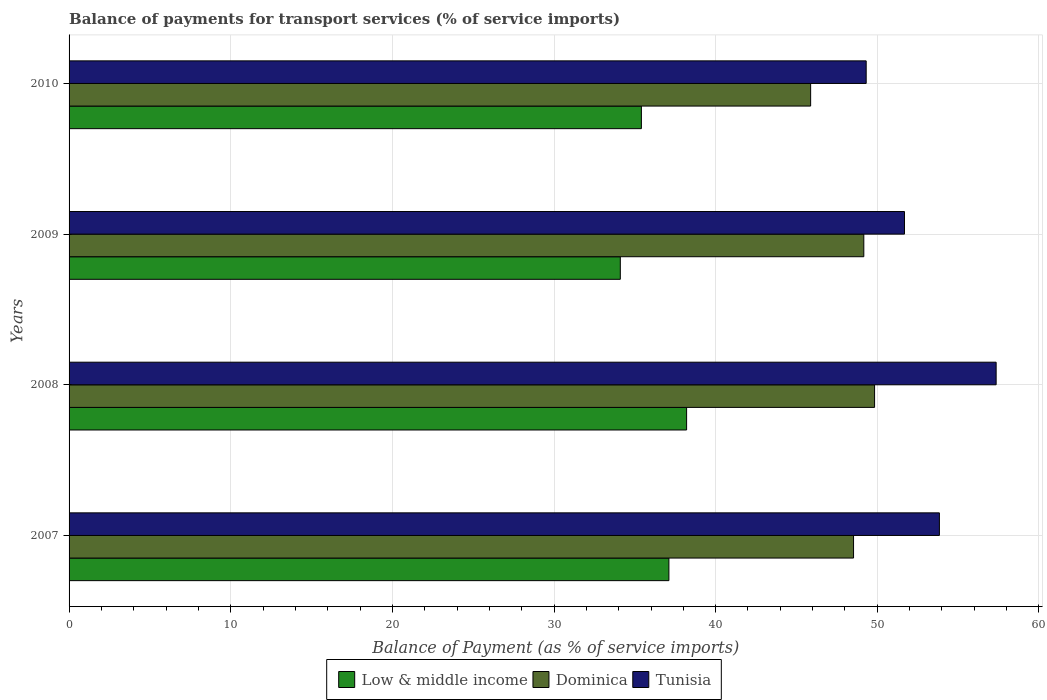How many different coloured bars are there?
Give a very brief answer. 3. How many groups of bars are there?
Provide a short and direct response. 4. Are the number of bars per tick equal to the number of legend labels?
Provide a succinct answer. Yes. How many bars are there on the 3rd tick from the top?
Ensure brevity in your answer.  3. What is the balance of payments for transport services in Low & middle income in 2007?
Provide a short and direct response. 37.11. Across all years, what is the maximum balance of payments for transport services in Tunisia?
Make the answer very short. 57.35. Across all years, what is the minimum balance of payments for transport services in Tunisia?
Your answer should be very brief. 49.31. In which year was the balance of payments for transport services in Low & middle income maximum?
Ensure brevity in your answer.  2008. In which year was the balance of payments for transport services in Low & middle income minimum?
Your response must be concise. 2009. What is the total balance of payments for transport services in Tunisia in the graph?
Your response must be concise. 212.19. What is the difference between the balance of payments for transport services in Low & middle income in 2009 and that in 2010?
Your response must be concise. -1.3. What is the difference between the balance of payments for transport services in Dominica in 2009 and the balance of payments for transport services in Tunisia in 2007?
Give a very brief answer. -4.68. What is the average balance of payments for transport services in Dominica per year?
Give a very brief answer. 48.35. In the year 2007, what is the difference between the balance of payments for transport services in Tunisia and balance of payments for transport services in Low & middle income?
Your answer should be compact. 16.73. What is the ratio of the balance of payments for transport services in Tunisia in 2008 to that in 2009?
Provide a short and direct response. 1.11. Is the balance of payments for transport services in Low & middle income in 2007 less than that in 2008?
Provide a short and direct response. Yes. Is the difference between the balance of payments for transport services in Tunisia in 2007 and 2008 greater than the difference between the balance of payments for transport services in Low & middle income in 2007 and 2008?
Keep it short and to the point. No. What is the difference between the highest and the second highest balance of payments for transport services in Tunisia?
Your answer should be compact. 3.51. What is the difference between the highest and the lowest balance of payments for transport services in Tunisia?
Ensure brevity in your answer.  8.04. In how many years, is the balance of payments for transport services in Tunisia greater than the average balance of payments for transport services in Tunisia taken over all years?
Your response must be concise. 2. Is it the case that in every year, the sum of the balance of payments for transport services in Dominica and balance of payments for transport services in Tunisia is greater than the balance of payments for transport services in Low & middle income?
Make the answer very short. Yes. How many years are there in the graph?
Your response must be concise. 4. What is the difference between two consecutive major ticks on the X-axis?
Your response must be concise. 10. Does the graph contain any zero values?
Provide a short and direct response. No. Does the graph contain grids?
Your answer should be compact. Yes. Where does the legend appear in the graph?
Offer a very short reply. Bottom center. What is the title of the graph?
Ensure brevity in your answer.  Balance of payments for transport services (% of service imports). Does "Macao" appear as one of the legend labels in the graph?
Your response must be concise. No. What is the label or title of the X-axis?
Give a very brief answer. Balance of Payment (as % of service imports). What is the Balance of Payment (as % of service imports) of Low & middle income in 2007?
Provide a short and direct response. 37.11. What is the Balance of Payment (as % of service imports) in Dominica in 2007?
Your answer should be very brief. 48.53. What is the Balance of Payment (as % of service imports) in Tunisia in 2007?
Make the answer very short. 53.84. What is the Balance of Payment (as % of service imports) of Low & middle income in 2008?
Offer a terse response. 38.2. What is the Balance of Payment (as % of service imports) in Dominica in 2008?
Give a very brief answer. 49.83. What is the Balance of Payment (as % of service imports) of Tunisia in 2008?
Give a very brief answer. 57.35. What is the Balance of Payment (as % of service imports) in Low & middle income in 2009?
Your response must be concise. 34.1. What is the Balance of Payment (as % of service imports) of Dominica in 2009?
Offer a terse response. 49.17. What is the Balance of Payment (as % of service imports) of Tunisia in 2009?
Make the answer very short. 51.68. What is the Balance of Payment (as % of service imports) in Low & middle income in 2010?
Offer a terse response. 35.41. What is the Balance of Payment (as % of service imports) of Dominica in 2010?
Offer a terse response. 45.88. What is the Balance of Payment (as % of service imports) in Tunisia in 2010?
Give a very brief answer. 49.31. Across all years, what is the maximum Balance of Payment (as % of service imports) in Low & middle income?
Offer a very short reply. 38.2. Across all years, what is the maximum Balance of Payment (as % of service imports) in Dominica?
Offer a very short reply. 49.83. Across all years, what is the maximum Balance of Payment (as % of service imports) in Tunisia?
Offer a terse response. 57.35. Across all years, what is the minimum Balance of Payment (as % of service imports) in Low & middle income?
Offer a very short reply. 34.1. Across all years, what is the minimum Balance of Payment (as % of service imports) of Dominica?
Your answer should be very brief. 45.88. Across all years, what is the minimum Balance of Payment (as % of service imports) of Tunisia?
Keep it short and to the point. 49.31. What is the total Balance of Payment (as % of service imports) of Low & middle income in the graph?
Give a very brief answer. 144.82. What is the total Balance of Payment (as % of service imports) in Dominica in the graph?
Ensure brevity in your answer.  193.4. What is the total Balance of Payment (as % of service imports) of Tunisia in the graph?
Ensure brevity in your answer.  212.19. What is the difference between the Balance of Payment (as % of service imports) in Low & middle income in 2007 and that in 2008?
Your answer should be very brief. -1.1. What is the difference between the Balance of Payment (as % of service imports) of Dominica in 2007 and that in 2008?
Keep it short and to the point. -1.3. What is the difference between the Balance of Payment (as % of service imports) of Tunisia in 2007 and that in 2008?
Provide a succinct answer. -3.51. What is the difference between the Balance of Payment (as % of service imports) of Low & middle income in 2007 and that in 2009?
Offer a very short reply. 3.01. What is the difference between the Balance of Payment (as % of service imports) in Dominica in 2007 and that in 2009?
Give a very brief answer. -0.63. What is the difference between the Balance of Payment (as % of service imports) in Tunisia in 2007 and that in 2009?
Offer a very short reply. 2.16. What is the difference between the Balance of Payment (as % of service imports) in Low & middle income in 2007 and that in 2010?
Make the answer very short. 1.7. What is the difference between the Balance of Payment (as % of service imports) of Dominica in 2007 and that in 2010?
Provide a short and direct response. 2.65. What is the difference between the Balance of Payment (as % of service imports) in Tunisia in 2007 and that in 2010?
Your answer should be compact. 4.53. What is the difference between the Balance of Payment (as % of service imports) in Low & middle income in 2008 and that in 2009?
Keep it short and to the point. 4.1. What is the difference between the Balance of Payment (as % of service imports) in Dominica in 2008 and that in 2009?
Your response must be concise. 0.67. What is the difference between the Balance of Payment (as % of service imports) in Tunisia in 2008 and that in 2009?
Your answer should be compact. 5.67. What is the difference between the Balance of Payment (as % of service imports) of Low & middle income in 2008 and that in 2010?
Ensure brevity in your answer.  2.8. What is the difference between the Balance of Payment (as % of service imports) of Dominica in 2008 and that in 2010?
Keep it short and to the point. 3.95. What is the difference between the Balance of Payment (as % of service imports) of Tunisia in 2008 and that in 2010?
Keep it short and to the point. 8.04. What is the difference between the Balance of Payment (as % of service imports) of Low & middle income in 2009 and that in 2010?
Keep it short and to the point. -1.3. What is the difference between the Balance of Payment (as % of service imports) in Dominica in 2009 and that in 2010?
Your answer should be compact. 3.29. What is the difference between the Balance of Payment (as % of service imports) in Tunisia in 2009 and that in 2010?
Provide a succinct answer. 2.37. What is the difference between the Balance of Payment (as % of service imports) in Low & middle income in 2007 and the Balance of Payment (as % of service imports) in Dominica in 2008?
Offer a very short reply. -12.72. What is the difference between the Balance of Payment (as % of service imports) of Low & middle income in 2007 and the Balance of Payment (as % of service imports) of Tunisia in 2008?
Make the answer very short. -20.24. What is the difference between the Balance of Payment (as % of service imports) in Dominica in 2007 and the Balance of Payment (as % of service imports) in Tunisia in 2008?
Your response must be concise. -8.82. What is the difference between the Balance of Payment (as % of service imports) in Low & middle income in 2007 and the Balance of Payment (as % of service imports) in Dominica in 2009?
Offer a very short reply. -12.06. What is the difference between the Balance of Payment (as % of service imports) of Low & middle income in 2007 and the Balance of Payment (as % of service imports) of Tunisia in 2009?
Your response must be concise. -14.57. What is the difference between the Balance of Payment (as % of service imports) of Dominica in 2007 and the Balance of Payment (as % of service imports) of Tunisia in 2009?
Your response must be concise. -3.15. What is the difference between the Balance of Payment (as % of service imports) in Low & middle income in 2007 and the Balance of Payment (as % of service imports) in Dominica in 2010?
Make the answer very short. -8.77. What is the difference between the Balance of Payment (as % of service imports) of Low & middle income in 2007 and the Balance of Payment (as % of service imports) of Tunisia in 2010?
Your answer should be compact. -12.2. What is the difference between the Balance of Payment (as % of service imports) in Dominica in 2007 and the Balance of Payment (as % of service imports) in Tunisia in 2010?
Your response must be concise. -0.78. What is the difference between the Balance of Payment (as % of service imports) in Low & middle income in 2008 and the Balance of Payment (as % of service imports) in Dominica in 2009?
Offer a terse response. -10.96. What is the difference between the Balance of Payment (as % of service imports) of Low & middle income in 2008 and the Balance of Payment (as % of service imports) of Tunisia in 2009?
Offer a very short reply. -13.48. What is the difference between the Balance of Payment (as % of service imports) of Dominica in 2008 and the Balance of Payment (as % of service imports) of Tunisia in 2009?
Provide a succinct answer. -1.85. What is the difference between the Balance of Payment (as % of service imports) in Low & middle income in 2008 and the Balance of Payment (as % of service imports) in Dominica in 2010?
Ensure brevity in your answer.  -7.67. What is the difference between the Balance of Payment (as % of service imports) of Low & middle income in 2008 and the Balance of Payment (as % of service imports) of Tunisia in 2010?
Ensure brevity in your answer.  -11.11. What is the difference between the Balance of Payment (as % of service imports) in Dominica in 2008 and the Balance of Payment (as % of service imports) in Tunisia in 2010?
Give a very brief answer. 0.52. What is the difference between the Balance of Payment (as % of service imports) in Low & middle income in 2009 and the Balance of Payment (as % of service imports) in Dominica in 2010?
Provide a short and direct response. -11.78. What is the difference between the Balance of Payment (as % of service imports) of Low & middle income in 2009 and the Balance of Payment (as % of service imports) of Tunisia in 2010?
Your answer should be very brief. -15.21. What is the difference between the Balance of Payment (as % of service imports) of Dominica in 2009 and the Balance of Payment (as % of service imports) of Tunisia in 2010?
Your answer should be compact. -0.15. What is the average Balance of Payment (as % of service imports) in Low & middle income per year?
Keep it short and to the point. 36.2. What is the average Balance of Payment (as % of service imports) in Dominica per year?
Give a very brief answer. 48.35. What is the average Balance of Payment (as % of service imports) of Tunisia per year?
Provide a succinct answer. 53.05. In the year 2007, what is the difference between the Balance of Payment (as % of service imports) in Low & middle income and Balance of Payment (as % of service imports) in Dominica?
Give a very brief answer. -11.42. In the year 2007, what is the difference between the Balance of Payment (as % of service imports) of Low & middle income and Balance of Payment (as % of service imports) of Tunisia?
Provide a short and direct response. -16.73. In the year 2007, what is the difference between the Balance of Payment (as % of service imports) of Dominica and Balance of Payment (as % of service imports) of Tunisia?
Offer a very short reply. -5.31. In the year 2008, what is the difference between the Balance of Payment (as % of service imports) in Low & middle income and Balance of Payment (as % of service imports) in Dominica?
Offer a terse response. -11.63. In the year 2008, what is the difference between the Balance of Payment (as % of service imports) of Low & middle income and Balance of Payment (as % of service imports) of Tunisia?
Provide a short and direct response. -19.15. In the year 2008, what is the difference between the Balance of Payment (as % of service imports) of Dominica and Balance of Payment (as % of service imports) of Tunisia?
Give a very brief answer. -7.52. In the year 2009, what is the difference between the Balance of Payment (as % of service imports) in Low & middle income and Balance of Payment (as % of service imports) in Dominica?
Your answer should be compact. -15.06. In the year 2009, what is the difference between the Balance of Payment (as % of service imports) in Low & middle income and Balance of Payment (as % of service imports) in Tunisia?
Offer a very short reply. -17.58. In the year 2009, what is the difference between the Balance of Payment (as % of service imports) of Dominica and Balance of Payment (as % of service imports) of Tunisia?
Offer a very short reply. -2.52. In the year 2010, what is the difference between the Balance of Payment (as % of service imports) of Low & middle income and Balance of Payment (as % of service imports) of Dominica?
Give a very brief answer. -10.47. In the year 2010, what is the difference between the Balance of Payment (as % of service imports) of Low & middle income and Balance of Payment (as % of service imports) of Tunisia?
Your answer should be very brief. -13.91. In the year 2010, what is the difference between the Balance of Payment (as % of service imports) of Dominica and Balance of Payment (as % of service imports) of Tunisia?
Your response must be concise. -3.44. What is the ratio of the Balance of Payment (as % of service imports) of Low & middle income in 2007 to that in 2008?
Offer a very short reply. 0.97. What is the ratio of the Balance of Payment (as % of service imports) in Dominica in 2007 to that in 2008?
Provide a short and direct response. 0.97. What is the ratio of the Balance of Payment (as % of service imports) in Tunisia in 2007 to that in 2008?
Your response must be concise. 0.94. What is the ratio of the Balance of Payment (as % of service imports) in Low & middle income in 2007 to that in 2009?
Ensure brevity in your answer.  1.09. What is the ratio of the Balance of Payment (as % of service imports) of Dominica in 2007 to that in 2009?
Provide a short and direct response. 0.99. What is the ratio of the Balance of Payment (as % of service imports) of Tunisia in 2007 to that in 2009?
Your answer should be very brief. 1.04. What is the ratio of the Balance of Payment (as % of service imports) of Low & middle income in 2007 to that in 2010?
Provide a short and direct response. 1.05. What is the ratio of the Balance of Payment (as % of service imports) of Dominica in 2007 to that in 2010?
Your answer should be compact. 1.06. What is the ratio of the Balance of Payment (as % of service imports) in Tunisia in 2007 to that in 2010?
Offer a very short reply. 1.09. What is the ratio of the Balance of Payment (as % of service imports) in Low & middle income in 2008 to that in 2009?
Provide a succinct answer. 1.12. What is the ratio of the Balance of Payment (as % of service imports) of Dominica in 2008 to that in 2009?
Give a very brief answer. 1.01. What is the ratio of the Balance of Payment (as % of service imports) in Tunisia in 2008 to that in 2009?
Your answer should be very brief. 1.11. What is the ratio of the Balance of Payment (as % of service imports) of Low & middle income in 2008 to that in 2010?
Ensure brevity in your answer.  1.08. What is the ratio of the Balance of Payment (as % of service imports) in Dominica in 2008 to that in 2010?
Ensure brevity in your answer.  1.09. What is the ratio of the Balance of Payment (as % of service imports) of Tunisia in 2008 to that in 2010?
Give a very brief answer. 1.16. What is the ratio of the Balance of Payment (as % of service imports) of Low & middle income in 2009 to that in 2010?
Make the answer very short. 0.96. What is the ratio of the Balance of Payment (as % of service imports) of Dominica in 2009 to that in 2010?
Provide a succinct answer. 1.07. What is the ratio of the Balance of Payment (as % of service imports) of Tunisia in 2009 to that in 2010?
Your response must be concise. 1.05. What is the difference between the highest and the second highest Balance of Payment (as % of service imports) of Low & middle income?
Give a very brief answer. 1.1. What is the difference between the highest and the second highest Balance of Payment (as % of service imports) in Dominica?
Your answer should be compact. 0.67. What is the difference between the highest and the second highest Balance of Payment (as % of service imports) in Tunisia?
Make the answer very short. 3.51. What is the difference between the highest and the lowest Balance of Payment (as % of service imports) of Low & middle income?
Provide a succinct answer. 4.1. What is the difference between the highest and the lowest Balance of Payment (as % of service imports) of Dominica?
Your response must be concise. 3.95. What is the difference between the highest and the lowest Balance of Payment (as % of service imports) in Tunisia?
Provide a short and direct response. 8.04. 